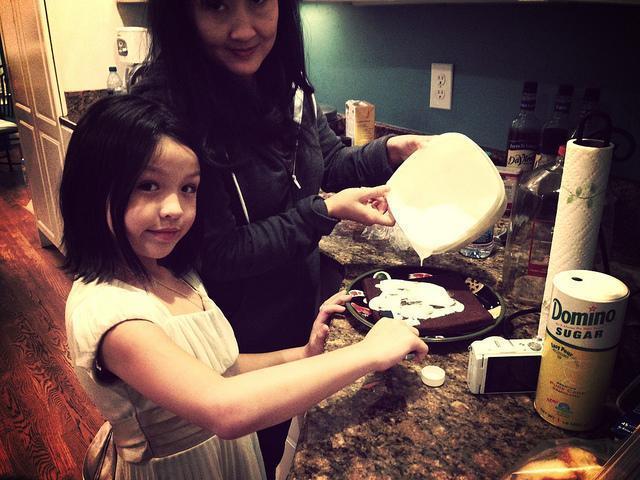How many people are there?
Give a very brief answer. 2. How many bottles are there?
Give a very brief answer. 1. 